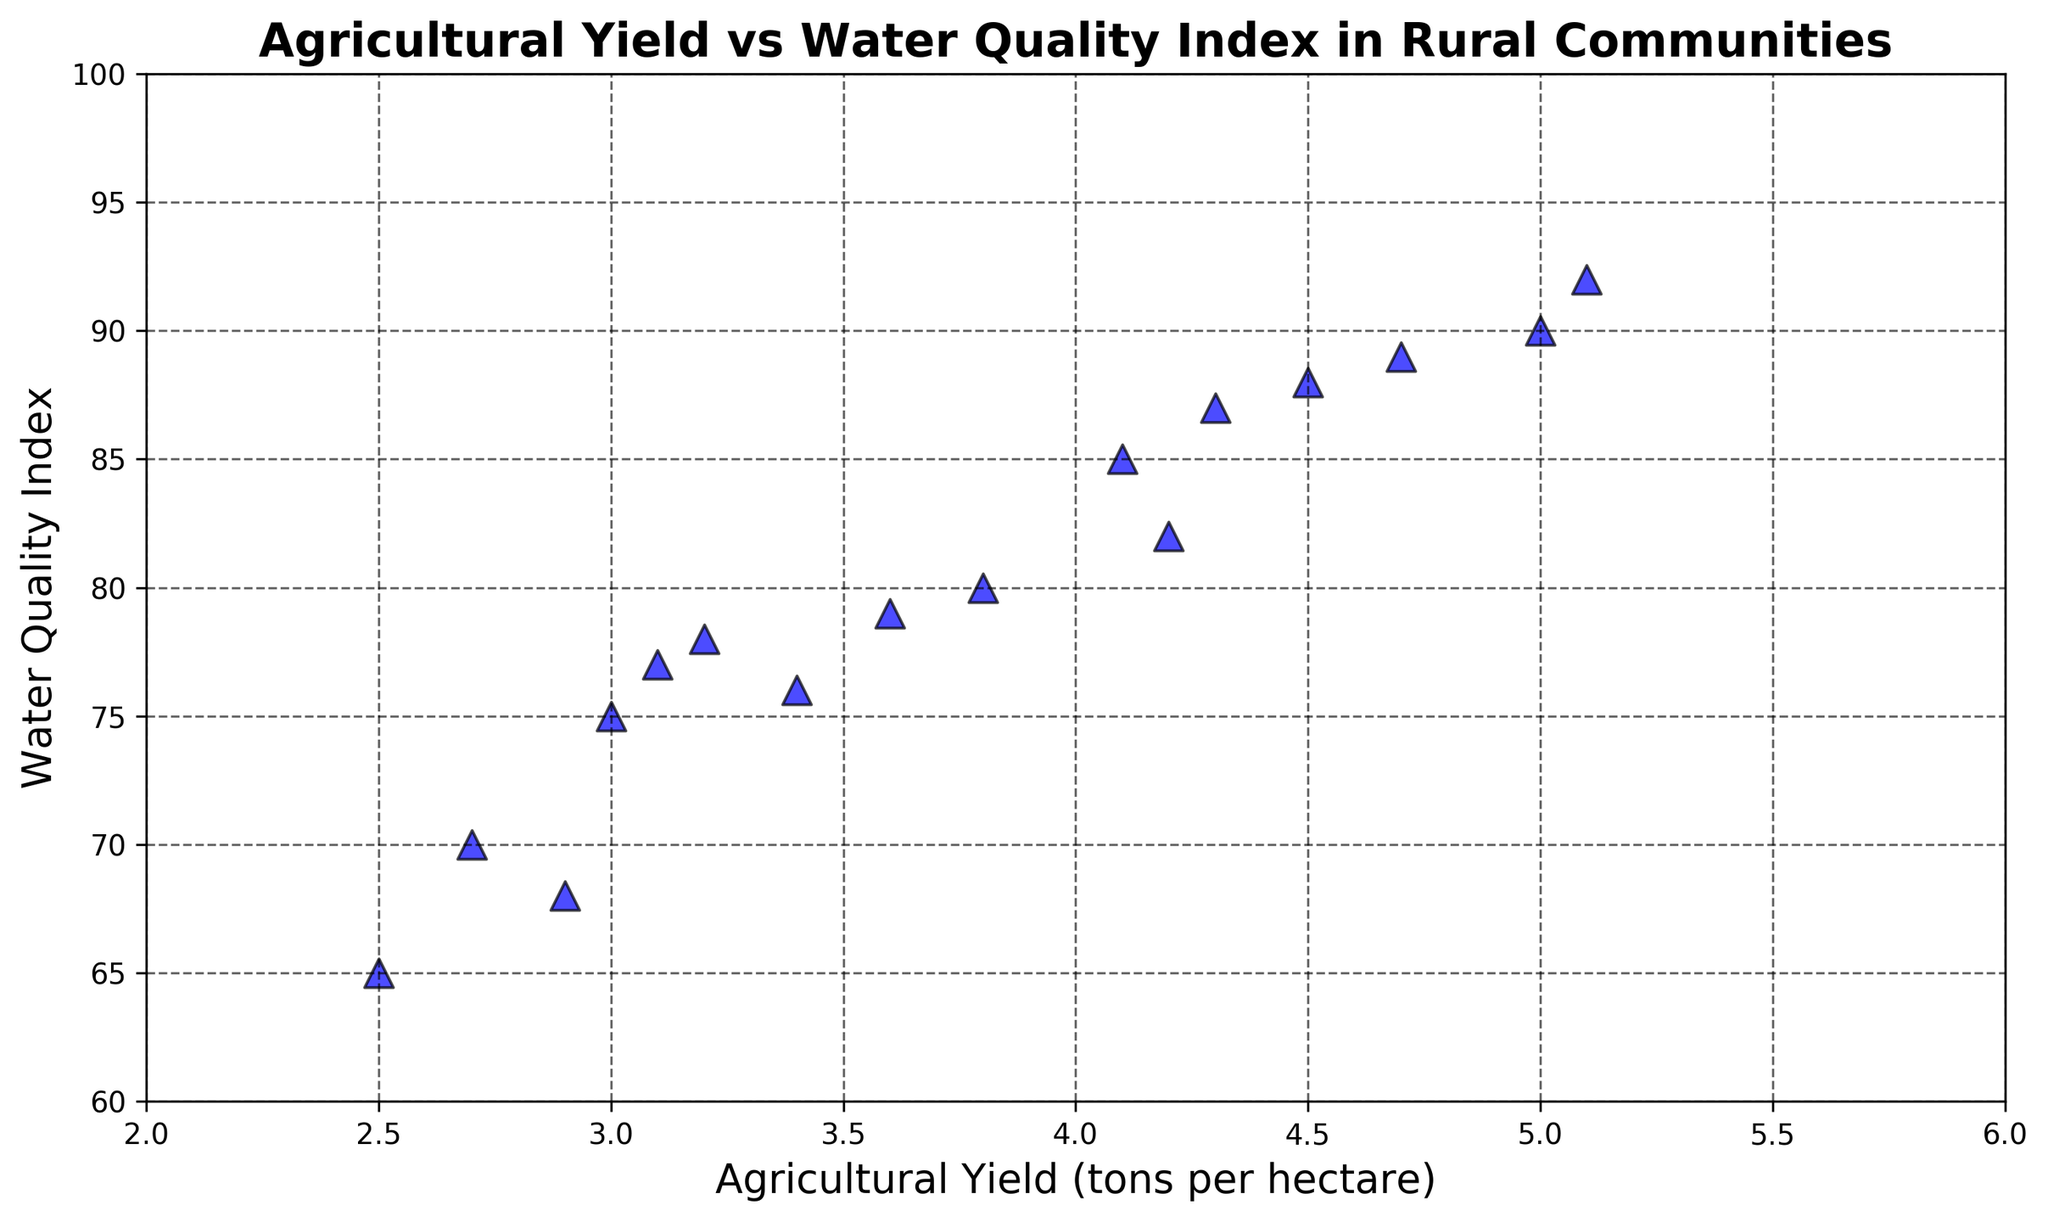What's the average Water Quality Index for the data points with Agricultural Yield above 4? First, identify the data points with Agricultural Yield above 4: 4.1, 5.0, 4.5, 4.2, 4.3, 5.1, 4.7. Next, find the corresponding Water Quality Index values: 85, 90, 88, 82, 87, 92, 89. Sum these values: 85 + 90 + 88 + 82 + 87 + 92 + 89 = 613. The number of data points is 7, so the average Water Quality Index is 613 / 7.
Answer: 87.57 Are there more data points with Agricultural Yield below 3 or above 4? Count the data points: below 3: 2.5, 2.7, 2.9 (3 points); above 4: 4.1, 4.5, 4.2, 4.3, 4.7, 5.0, 5.1 (7 points). Compare the counts: 3 points (below 3) vs. 7 points (above 4).
Answer: Above 4 Which data point has the highest Water Quality Index, and what is its Agricultural Yield? Identify the highest Water Quality Index value in the scatter plot, which is 92. The corresponding Agricultural Yield for this point is 5.1.
Answer: Agricultural Yield: 5.1 What is the range of the Agricultural Yield values? Identify the minimum and maximum Agricultural Yield values from the scatter plot: min is 2.5 and max is 5.1. Calculate the range: 5.1 - 2.5 = 2.6.
Answer: 2.6 Is there a noticeable trend in the relationship between Agricultural Yield and Water Quality Index? Observe the scatter plot to identify any patterns or trends. Generally, as Agricultural Yield increases, the Water Quality Index also tends to increase, suggesting a positive correlation.
Answer: Positive correlation 